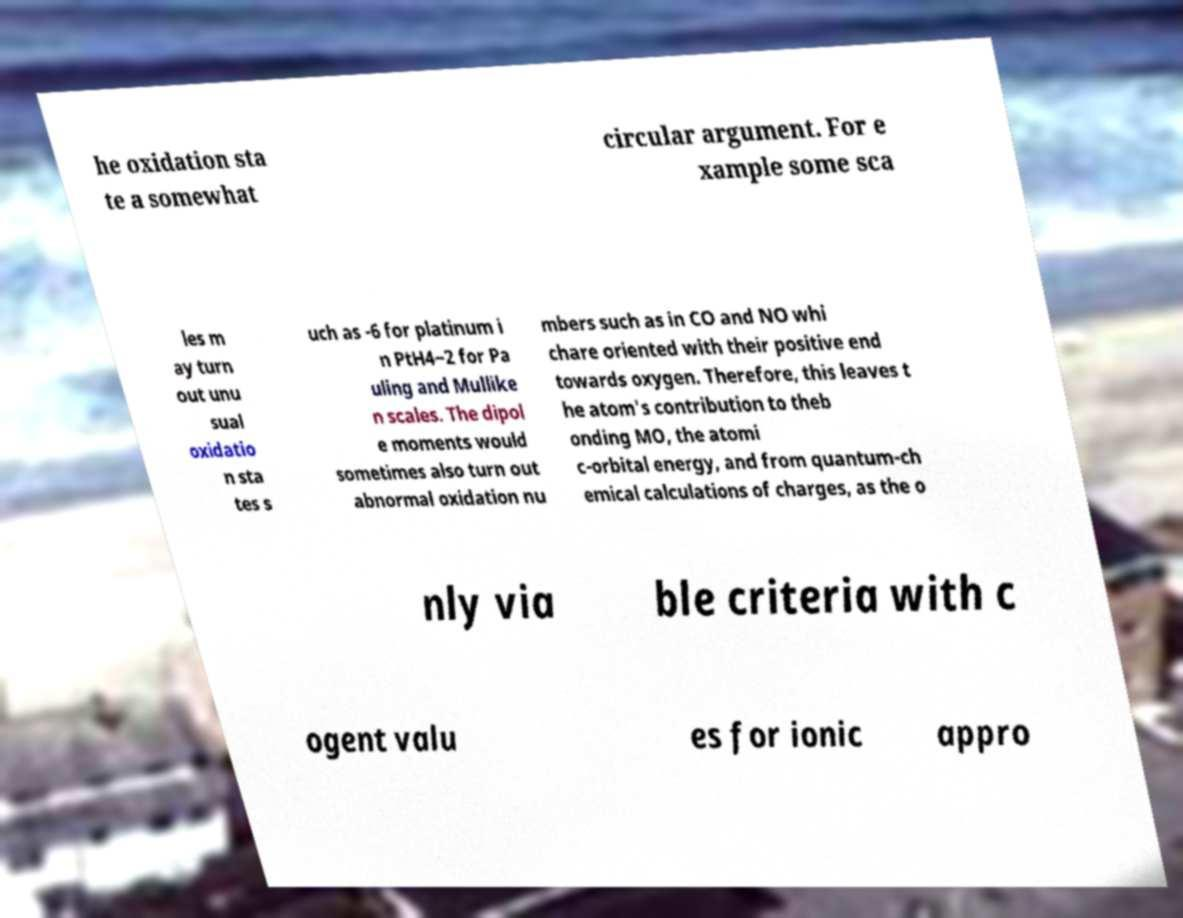There's text embedded in this image that I need extracted. Can you transcribe it verbatim? he oxidation sta te a somewhat circular argument. For e xample some sca les m ay turn out unu sual oxidatio n sta tes s uch as -6 for platinum i n PtH4−2 for Pa uling and Mullike n scales. The dipol e moments would sometimes also turn out abnormal oxidation nu mbers such as in CO and NO whi chare oriented with their positive end towards oxygen. Therefore, this leaves t he atom's contribution to theb onding MO, the atomi c-orbital energy, and from quantum-ch emical calculations of charges, as the o nly via ble criteria with c ogent valu es for ionic appro 